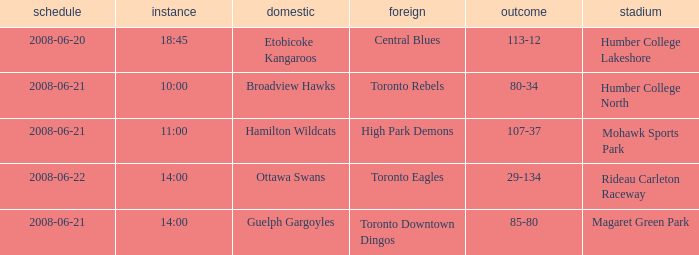What is the Time with a Ground that is humber college north? 10:00. 